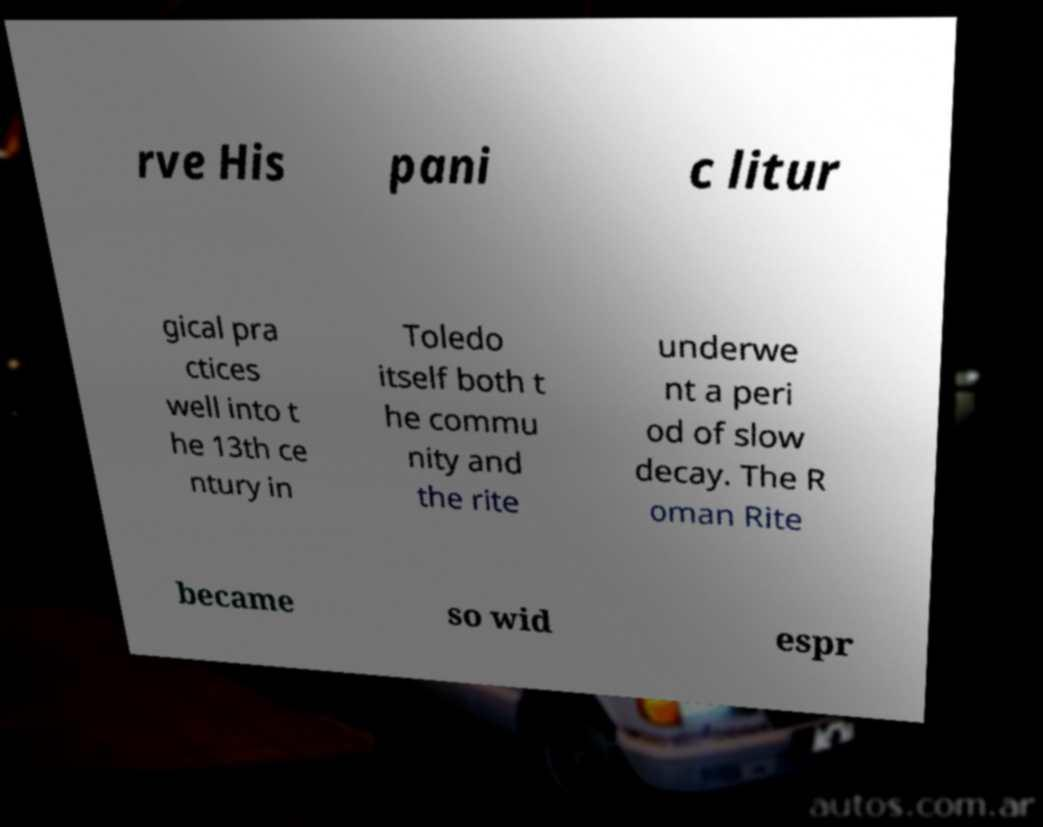Please read and relay the text visible in this image. What does it say? rve His pani c litur gical pra ctices well into t he 13th ce ntury in Toledo itself both t he commu nity and the rite underwe nt a peri od of slow decay. The R oman Rite became so wid espr 